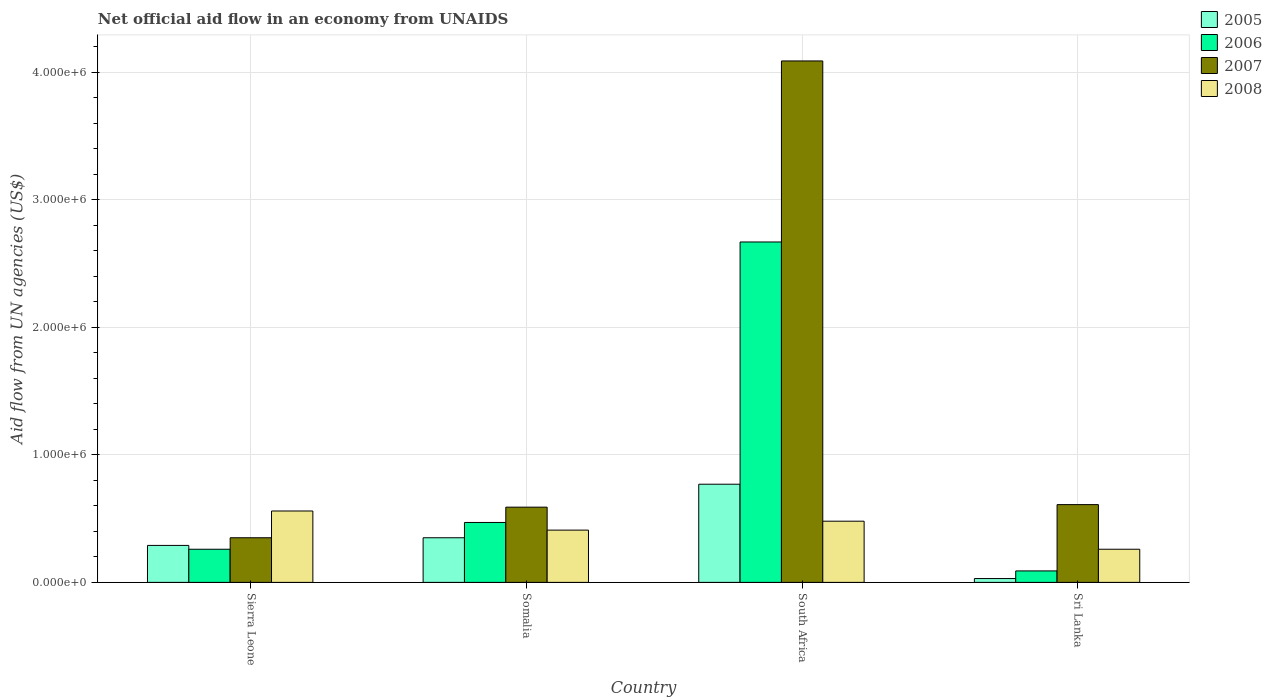How many groups of bars are there?
Provide a short and direct response. 4. Are the number of bars per tick equal to the number of legend labels?
Your response must be concise. Yes. Are the number of bars on each tick of the X-axis equal?
Ensure brevity in your answer.  Yes. What is the label of the 2nd group of bars from the left?
Ensure brevity in your answer.  Somalia. Across all countries, what is the maximum net official aid flow in 2008?
Your answer should be compact. 5.60e+05. Across all countries, what is the minimum net official aid flow in 2008?
Provide a succinct answer. 2.60e+05. In which country was the net official aid flow in 2008 maximum?
Offer a terse response. Sierra Leone. In which country was the net official aid flow in 2008 minimum?
Make the answer very short. Sri Lanka. What is the total net official aid flow in 2008 in the graph?
Give a very brief answer. 1.71e+06. What is the difference between the net official aid flow in 2007 in Sierra Leone and that in Sri Lanka?
Offer a very short reply. -2.60e+05. What is the difference between the net official aid flow in 2006 in Sri Lanka and the net official aid flow in 2008 in Somalia?
Your answer should be compact. -3.20e+05. What is the average net official aid flow in 2006 per country?
Your answer should be compact. 8.72e+05. What is the difference between the net official aid flow of/in 2008 and net official aid flow of/in 2006 in Sri Lanka?
Keep it short and to the point. 1.70e+05. What is the ratio of the net official aid flow in 2005 in Sierra Leone to that in Somalia?
Your answer should be compact. 0.83. Is the net official aid flow in 2005 in Somalia less than that in Sri Lanka?
Your answer should be compact. No. What is the difference between the highest and the second highest net official aid flow in 2006?
Offer a terse response. 2.20e+06. What is the difference between the highest and the lowest net official aid flow in 2005?
Ensure brevity in your answer.  7.40e+05. Is it the case that in every country, the sum of the net official aid flow in 2008 and net official aid flow in 2005 is greater than the net official aid flow in 2006?
Keep it short and to the point. No. Are all the bars in the graph horizontal?
Offer a very short reply. No. Does the graph contain grids?
Ensure brevity in your answer.  Yes. How many legend labels are there?
Your answer should be compact. 4. What is the title of the graph?
Keep it short and to the point. Net official aid flow in an economy from UNAIDS. Does "1986" appear as one of the legend labels in the graph?
Keep it short and to the point. No. What is the label or title of the X-axis?
Give a very brief answer. Country. What is the label or title of the Y-axis?
Offer a very short reply. Aid flow from UN agencies (US$). What is the Aid flow from UN agencies (US$) of 2005 in Sierra Leone?
Offer a terse response. 2.90e+05. What is the Aid flow from UN agencies (US$) of 2008 in Sierra Leone?
Your answer should be very brief. 5.60e+05. What is the Aid flow from UN agencies (US$) in 2006 in Somalia?
Your answer should be very brief. 4.70e+05. What is the Aid flow from UN agencies (US$) in 2007 in Somalia?
Offer a terse response. 5.90e+05. What is the Aid flow from UN agencies (US$) of 2005 in South Africa?
Your answer should be compact. 7.70e+05. What is the Aid flow from UN agencies (US$) in 2006 in South Africa?
Offer a terse response. 2.67e+06. What is the Aid flow from UN agencies (US$) in 2007 in South Africa?
Keep it short and to the point. 4.09e+06. What is the Aid flow from UN agencies (US$) in 2007 in Sri Lanka?
Provide a short and direct response. 6.10e+05. Across all countries, what is the maximum Aid flow from UN agencies (US$) of 2005?
Make the answer very short. 7.70e+05. Across all countries, what is the maximum Aid flow from UN agencies (US$) in 2006?
Your answer should be compact. 2.67e+06. Across all countries, what is the maximum Aid flow from UN agencies (US$) of 2007?
Your response must be concise. 4.09e+06. Across all countries, what is the maximum Aid flow from UN agencies (US$) of 2008?
Provide a short and direct response. 5.60e+05. Across all countries, what is the minimum Aid flow from UN agencies (US$) of 2005?
Offer a very short reply. 3.00e+04. What is the total Aid flow from UN agencies (US$) of 2005 in the graph?
Ensure brevity in your answer.  1.44e+06. What is the total Aid flow from UN agencies (US$) of 2006 in the graph?
Keep it short and to the point. 3.49e+06. What is the total Aid flow from UN agencies (US$) in 2007 in the graph?
Ensure brevity in your answer.  5.64e+06. What is the total Aid flow from UN agencies (US$) in 2008 in the graph?
Offer a very short reply. 1.71e+06. What is the difference between the Aid flow from UN agencies (US$) of 2006 in Sierra Leone and that in Somalia?
Provide a succinct answer. -2.10e+05. What is the difference between the Aid flow from UN agencies (US$) of 2005 in Sierra Leone and that in South Africa?
Give a very brief answer. -4.80e+05. What is the difference between the Aid flow from UN agencies (US$) in 2006 in Sierra Leone and that in South Africa?
Provide a short and direct response. -2.41e+06. What is the difference between the Aid flow from UN agencies (US$) in 2007 in Sierra Leone and that in South Africa?
Your answer should be compact. -3.74e+06. What is the difference between the Aid flow from UN agencies (US$) of 2006 in Sierra Leone and that in Sri Lanka?
Ensure brevity in your answer.  1.70e+05. What is the difference between the Aid flow from UN agencies (US$) of 2008 in Sierra Leone and that in Sri Lanka?
Your response must be concise. 3.00e+05. What is the difference between the Aid flow from UN agencies (US$) of 2005 in Somalia and that in South Africa?
Ensure brevity in your answer.  -4.20e+05. What is the difference between the Aid flow from UN agencies (US$) in 2006 in Somalia and that in South Africa?
Offer a terse response. -2.20e+06. What is the difference between the Aid flow from UN agencies (US$) in 2007 in Somalia and that in South Africa?
Provide a succinct answer. -3.50e+06. What is the difference between the Aid flow from UN agencies (US$) in 2008 in Somalia and that in South Africa?
Make the answer very short. -7.00e+04. What is the difference between the Aid flow from UN agencies (US$) in 2005 in Somalia and that in Sri Lanka?
Give a very brief answer. 3.20e+05. What is the difference between the Aid flow from UN agencies (US$) in 2006 in Somalia and that in Sri Lanka?
Give a very brief answer. 3.80e+05. What is the difference between the Aid flow from UN agencies (US$) of 2007 in Somalia and that in Sri Lanka?
Provide a succinct answer. -2.00e+04. What is the difference between the Aid flow from UN agencies (US$) of 2005 in South Africa and that in Sri Lanka?
Offer a terse response. 7.40e+05. What is the difference between the Aid flow from UN agencies (US$) of 2006 in South Africa and that in Sri Lanka?
Provide a short and direct response. 2.58e+06. What is the difference between the Aid flow from UN agencies (US$) in 2007 in South Africa and that in Sri Lanka?
Provide a short and direct response. 3.48e+06. What is the difference between the Aid flow from UN agencies (US$) in 2005 in Sierra Leone and the Aid flow from UN agencies (US$) in 2007 in Somalia?
Ensure brevity in your answer.  -3.00e+05. What is the difference between the Aid flow from UN agencies (US$) of 2006 in Sierra Leone and the Aid flow from UN agencies (US$) of 2007 in Somalia?
Give a very brief answer. -3.30e+05. What is the difference between the Aid flow from UN agencies (US$) of 2007 in Sierra Leone and the Aid flow from UN agencies (US$) of 2008 in Somalia?
Your answer should be very brief. -6.00e+04. What is the difference between the Aid flow from UN agencies (US$) of 2005 in Sierra Leone and the Aid flow from UN agencies (US$) of 2006 in South Africa?
Provide a short and direct response. -2.38e+06. What is the difference between the Aid flow from UN agencies (US$) in 2005 in Sierra Leone and the Aid flow from UN agencies (US$) in 2007 in South Africa?
Your response must be concise. -3.80e+06. What is the difference between the Aid flow from UN agencies (US$) in 2005 in Sierra Leone and the Aid flow from UN agencies (US$) in 2008 in South Africa?
Keep it short and to the point. -1.90e+05. What is the difference between the Aid flow from UN agencies (US$) of 2006 in Sierra Leone and the Aid flow from UN agencies (US$) of 2007 in South Africa?
Make the answer very short. -3.83e+06. What is the difference between the Aid flow from UN agencies (US$) of 2007 in Sierra Leone and the Aid flow from UN agencies (US$) of 2008 in South Africa?
Offer a terse response. -1.30e+05. What is the difference between the Aid flow from UN agencies (US$) of 2005 in Sierra Leone and the Aid flow from UN agencies (US$) of 2006 in Sri Lanka?
Offer a terse response. 2.00e+05. What is the difference between the Aid flow from UN agencies (US$) in 2005 in Sierra Leone and the Aid flow from UN agencies (US$) in 2007 in Sri Lanka?
Your answer should be very brief. -3.20e+05. What is the difference between the Aid flow from UN agencies (US$) of 2005 in Sierra Leone and the Aid flow from UN agencies (US$) of 2008 in Sri Lanka?
Make the answer very short. 3.00e+04. What is the difference between the Aid flow from UN agencies (US$) of 2006 in Sierra Leone and the Aid flow from UN agencies (US$) of 2007 in Sri Lanka?
Your answer should be compact. -3.50e+05. What is the difference between the Aid flow from UN agencies (US$) in 2006 in Sierra Leone and the Aid flow from UN agencies (US$) in 2008 in Sri Lanka?
Make the answer very short. 0. What is the difference between the Aid flow from UN agencies (US$) in 2005 in Somalia and the Aid flow from UN agencies (US$) in 2006 in South Africa?
Provide a succinct answer. -2.32e+06. What is the difference between the Aid flow from UN agencies (US$) in 2005 in Somalia and the Aid flow from UN agencies (US$) in 2007 in South Africa?
Offer a terse response. -3.74e+06. What is the difference between the Aid flow from UN agencies (US$) in 2005 in Somalia and the Aid flow from UN agencies (US$) in 2008 in South Africa?
Ensure brevity in your answer.  -1.30e+05. What is the difference between the Aid flow from UN agencies (US$) of 2006 in Somalia and the Aid flow from UN agencies (US$) of 2007 in South Africa?
Provide a short and direct response. -3.62e+06. What is the difference between the Aid flow from UN agencies (US$) in 2006 in Somalia and the Aid flow from UN agencies (US$) in 2007 in Sri Lanka?
Your answer should be very brief. -1.40e+05. What is the difference between the Aid flow from UN agencies (US$) in 2006 in Somalia and the Aid flow from UN agencies (US$) in 2008 in Sri Lanka?
Your answer should be compact. 2.10e+05. What is the difference between the Aid flow from UN agencies (US$) in 2005 in South Africa and the Aid flow from UN agencies (US$) in 2006 in Sri Lanka?
Give a very brief answer. 6.80e+05. What is the difference between the Aid flow from UN agencies (US$) in 2005 in South Africa and the Aid flow from UN agencies (US$) in 2008 in Sri Lanka?
Keep it short and to the point. 5.10e+05. What is the difference between the Aid flow from UN agencies (US$) in 2006 in South Africa and the Aid flow from UN agencies (US$) in 2007 in Sri Lanka?
Offer a very short reply. 2.06e+06. What is the difference between the Aid flow from UN agencies (US$) of 2006 in South Africa and the Aid flow from UN agencies (US$) of 2008 in Sri Lanka?
Offer a terse response. 2.41e+06. What is the difference between the Aid flow from UN agencies (US$) in 2007 in South Africa and the Aid flow from UN agencies (US$) in 2008 in Sri Lanka?
Make the answer very short. 3.83e+06. What is the average Aid flow from UN agencies (US$) in 2005 per country?
Keep it short and to the point. 3.60e+05. What is the average Aid flow from UN agencies (US$) in 2006 per country?
Your response must be concise. 8.72e+05. What is the average Aid flow from UN agencies (US$) of 2007 per country?
Provide a succinct answer. 1.41e+06. What is the average Aid flow from UN agencies (US$) in 2008 per country?
Make the answer very short. 4.28e+05. What is the difference between the Aid flow from UN agencies (US$) of 2005 and Aid flow from UN agencies (US$) of 2008 in Sierra Leone?
Keep it short and to the point. -2.70e+05. What is the difference between the Aid flow from UN agencies (US$) in 2006 and Aid flow from UN agencies (US$) in 2007 in Sierra Leone?
Give a very brief answer. -9.00e+04. What is the difference between the Aid flow from UN agencies (US$) in 2006 and Aid flow from UN agencies (US$) in 2008 in Sierra Leone?
Give a very brief answer. -3.00e+05. What is the difference between the Aid flow from UN agencies (US$) in 2007 and Aid flow from UN agencies (US$) in 2008 in Sierra Leone?
Offer a very short reply. -2.10e+05. What is the difference between the Aid flow from UN agencies (US$) in 2005 and Aid flow from UN agencies (US$) in 2007 in Somalia?
Your answer should be very brief. -2.40e+05. What is the difference between the Aid flow from UN agencies (US$) in 2007 and Aid flow from UN agencies (US$) in 2008 in Somalia?
Provide a succinct answer. 1.80e+05. What is the difference between the Aid flow from UN agencies (US$) in 2005 and Aid flow from UN agencies (US$) in 2006 in South Africa?
Your answer should be very brief. -1.90e+06. What is the difference between the Aid flow from UN agencies (US$) in 2005 and Aid flow from UN agencies (US$) in 2007 in South Africa?
Provide a short and direct response. -3.32e+06. What is the difference between the Aid flow from UN agencies (US$) in 2006 and Aid flow from UN agencies (US$) in 2007 in South Africa?
Give a very brief answer. -1.42e+06. What is the difference between the Aid flow from UN agencies (US$) of 2006 and Aid flow from UN agencies (US$) of 2008 in South Africa?
Make the answer very short. 2.19e+06. What is the difference between the Aid flow from UN agencies (US$) of 2007 and Aid flow from UN agencies (US$) of 2008 in South Africa?
Keep it short and to the point. 3.61e+06. What is the difference between the Aid flow from UN agencies (US$) in 2005 and Aid flow from UN agencies (US$) in 2007 in Sri Lanka?
Ensure brevity in your answer.  -5.80e+05. What is the difference between the Aid flow from UN agencies (US$) of 2006 and Aid flow from UN agencies (US$) of 2007 in Sri Lanka?
Make the answer very short. -5.20e+05. What is the difference between the Aid flow from UN agencies (US$) of 2007 and Aid flow from UN agencies (US$) of 2008 in Sri Lanka?
Ensure brevity in your answer.  3.50e+05. What is the ratio of the Aid flow from UN agencies (US$) in 2005 in Sierra Leone to that in Somalia?
Make the answer very short. 0.83. What is the ratio of the Aid flow from UN agencies (US$) in 2006 in Sierra Leone to that in Somalia?
Offer a very short reply. 0.55. What is the ratio of the Aid flow from UN agencies (US$) in 2007 in Sierra Leone to that in Somalia?
Offer a very short reply. 0.59. What is the ratio of the Aid flow from UN agencies (US$) in 2008 in Sierra Leone to that in Somalia?
Give a very brief answer. 1.37. What is the ratio of the Aid flow from UN agencies (US$) of 2005 in Sierra Leone to that in South Africa?
Ensure brevity in your answer.  0.38. What is the ratio of the Aid flow from UN agencies (US$) in 2006 in Sierra Leone to that in South Africa?
Your response must be concise. 0.1. What is the ratio of the Aid flow from UN agencies (US$) in 2007 in Sierra Leone to that in South Africa?
Ensure brevity in your answer.  0.09. What is the ratio of the Aid flow from UN agencies (US$) of 2008 in Sierra Leone to that in South Africa?
Your answer should be very brief. 1.17. What is the ratio of the Aid flow from UN agencies (US$) of 2005 in Sierra Leone to that in Sri Lanka?
Your answer should be compact. 9.67. What is the ratio of the Aid flow from UN agencies (US$) in 2006 in Sierra Leone to that in Sri Lanka?
Your answer should be very brief. 2.89. What is the ratio of the Aid flow from UN agencies (US$) in 2007 in Sierra Leone to that in Sri Lanka?
Your answer should be compact. 0.57. What is the ratio of the Aid flow from UN agencies (US$) in 2008 in Sierra Leone to that in Sri Lanka?
Provide a succinct answer. 2.15. What is the ratio of the Aid flow from UN agencies (US$) of 2005 in Somalia to that in South Africa?
Offer a very short reply. 0.45. What is the ratio of the Aid flow from UN agencies (US$) of 2006 in Somalia to that in South Africa?
Your answer should be very brief. 0.18. What is the ratio of the Aid flow from UN agencies (US$) of 2007 in Somalia to that in South Africa?
Your response must be concise. 0.14. What is the ratio of the Aid flow from UN agencies (US$) in 2008 in Somalia to that in South Africa?
Ensure brevity in your answer.  0.85. What is the ratio of the Aid flow from UN agencies (US$) of 2005 in Somalia to that in Sri Lanka?
Ensure brevity in your answer.  11.67. What is the ratio of the Aid flow from UN agencies (US$) of 2006 in Somalia to that in Sri Lanka?
Keep it short and to the point. 5.22. What is the ratio of the Aid flow from UN agencies (US$) of 2007 in Somalia to that in Sri Lanka?
Provide a succinct answer. 0.97. What is the ratio of the Aid flow from UN agencies (US$) in 2008 in Somalia to that in Sri Lanka?
Keep it short and to the point. 1.58. What is the ratio of the Aid flow from UN agencies (US$) of 2005 in South Africa to that in Sri Lanka?
Keep it short and to the point. 25.67. What is the ratio of the Aid flow from UN agencies (US$) of 2006 in South Africa to that in Sri Lanka?
Provide a short and direct response. 29.67. What is the ratio of the Aid flow from UN agencies (US$) of 2007 in South Africa to that in Sri Lanka?
Offer a very short reply. 6.7. What is the ratio of the Aid flow from UN agencies (US$) in 2008 in South Africa to that in Sri Lanka?
Your answer should be very brief. 1.85. What is the difference between the highest and the second highest Aid flow from UN agencies (US$) in 2005?
Provide a succinct answer. 4.20e+05. What is the difference between the highest and the second highest Aid flow from UN agencies (US$) in 2006?
Provide a succinct answer. 2.20e+06. What is the difference between the highest and the second highest Aid flow from UN agencies (US$) of 2007?
Offer a very short reply. 3.48e+06. What is the difference between the highest and the second highest Aid flow from UN agencies (US$) of 2008?
Your response must be concise. 8.00e+04. What is the difference between the highest and the lowest Aid flow from UN agencies (US$) in 2005?
Offer a terse response. 7.40e+05. What is the difference between the highest and the lowest Aid flow from UN agencies (US$) in 2006?
Offer a terse response. 2.58e+06. What is the difference between the highest and the lowest Aid flow from UN agencies (US$) of 2007?
Give a very brief answer. 3.74e+06. 